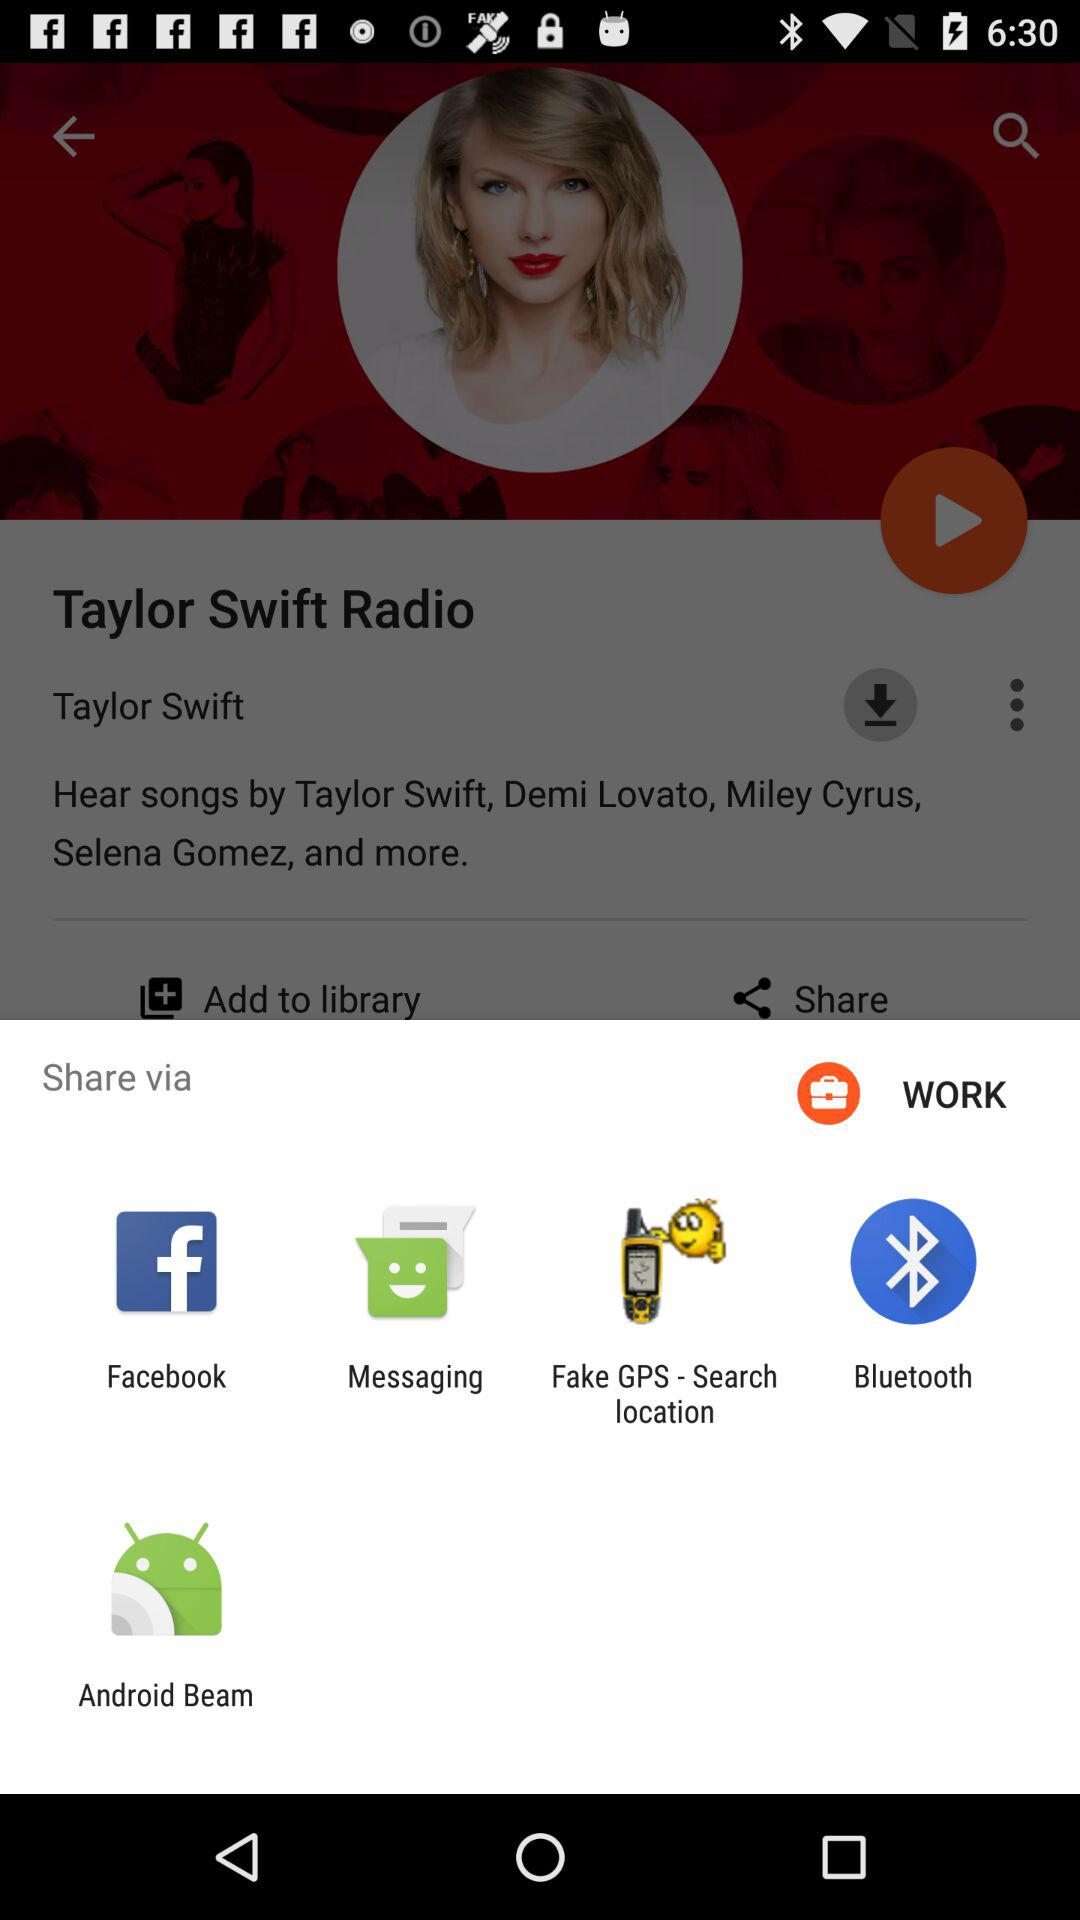What are the sharing options? The sharing options are "Facebook", "Messaging", "Fake GPS - Search location", "Bluetooth" and "Android Beam". 